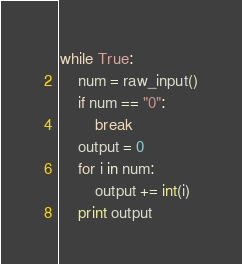Convert code to text. <code><loc_0><loc_0><loc_500><loc_500><_Python_>while True:
    num = raw_input()
    if num == "0":
        break
    output = 0
    for i in num:
        output += int(i)
    print output</code> 